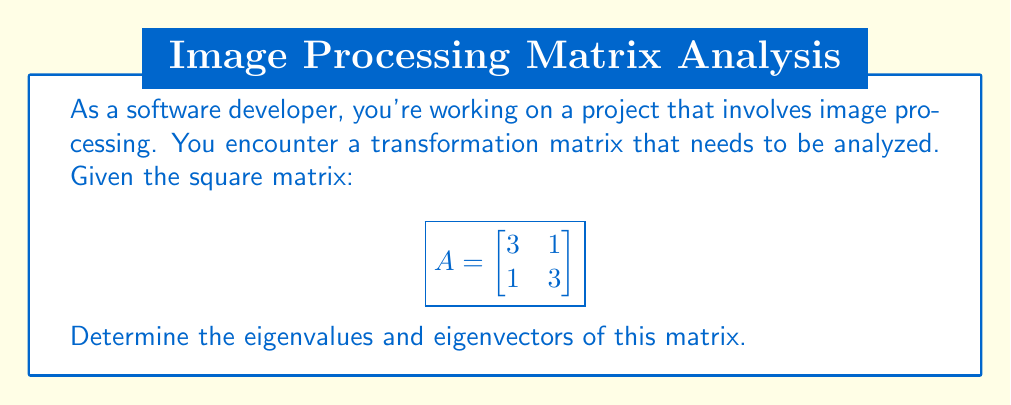Show me your answer to this math problem. Let's solve this step-by-step:

1) To find eigenvalues, we need to solve the characteristic equation:
   $det(A - \lambda I) = 0$, where $I$ is the identity matrix.

2) Expand the determinant:
   $$det\begin{pmatrix}
   3-\lambda & 1 \\
   1 & 3-\lambda
   \end{pmatrix} = 0$$

3) Calculate the determinant:
   $(3-\lambda)(3-\lambda) - 1 = 0$
   $(3-\lambda)^2 - 1 = 0$

4) Solve the quadratic equation:
   $\lambda^2 - 6\lambda + 8 = 0$
   $(\lambda - 4)(\lambda - 2) = 0$

5) The eigenvalues are $\lambda_1 = 4$ and $\lambda_2 = 2$

6) For eigenvectors, solve $(A - \lambda I)v = 0$ for each eigenvalue:

   For $\lambda_1 = 4$:
   $$\begin{pmatrix}
   -1 & 1 \\
   1 & -1
   \end{pmatrix}\begin{pmatrix}
   v_1 \\
   v_2
   \end{pmatrix} = \begin{pmatrix}
   0 \\
   0
   \end{pmatrix}$$

   This gives us $v_1 = v_2$. Let $v_1 = 1$, then $v_2 = 1$.
   Eigenvector for $\lambda_1$: $v_1 = \begin{pmatrix} 1 \\ 1 \end{pmatrix}$

   For $\lambda_2 = 2$:
   $$\begin{pmatrix}
   1 & 1 \\
   1 & 1
   \end{pmatrix}\begin{pmatrix}
   v_1 \\
   v_2
   \end{pmatrix} = \begin{pmatrix}
   0 \\
   0
   \end{pmatrix}$$

   This gives us $v_1 = -v_2$. Let $v_1 = 1$, then $v_2 = -1$.
   Eigenvector for $\lambda_2$: $v_2 = \begin{pmatrix} 1 \\ -1 \end{pmatrix}$
Answer: Eigenvalues: $\lambda_1 = 4$, $\lambda_2 = 2$
Eigenvectors: $v_1 = \begin{pmatrix} 1 \\ 1 \end{pmatrix}$, $v_2 = \begin{pmatrix} 1 \\ -1 \end{pmatrix}$ 